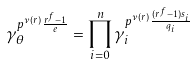Convert formula to latex. <formula><loc_0><loc_0><loc_500><loc_500>\gamma _ { \theta } ^ { p ^ { \nu ( r ) } \frac { r ^ { f } - 1 } { e } } = \prod _ { i = 0 } ^ { n } \gamma _ { i } ^ { p ^ { \nu ( r ) } \frac { ( r ^ { f } - 1 ) s _ { i } } { q _ { i } } }</formula> 